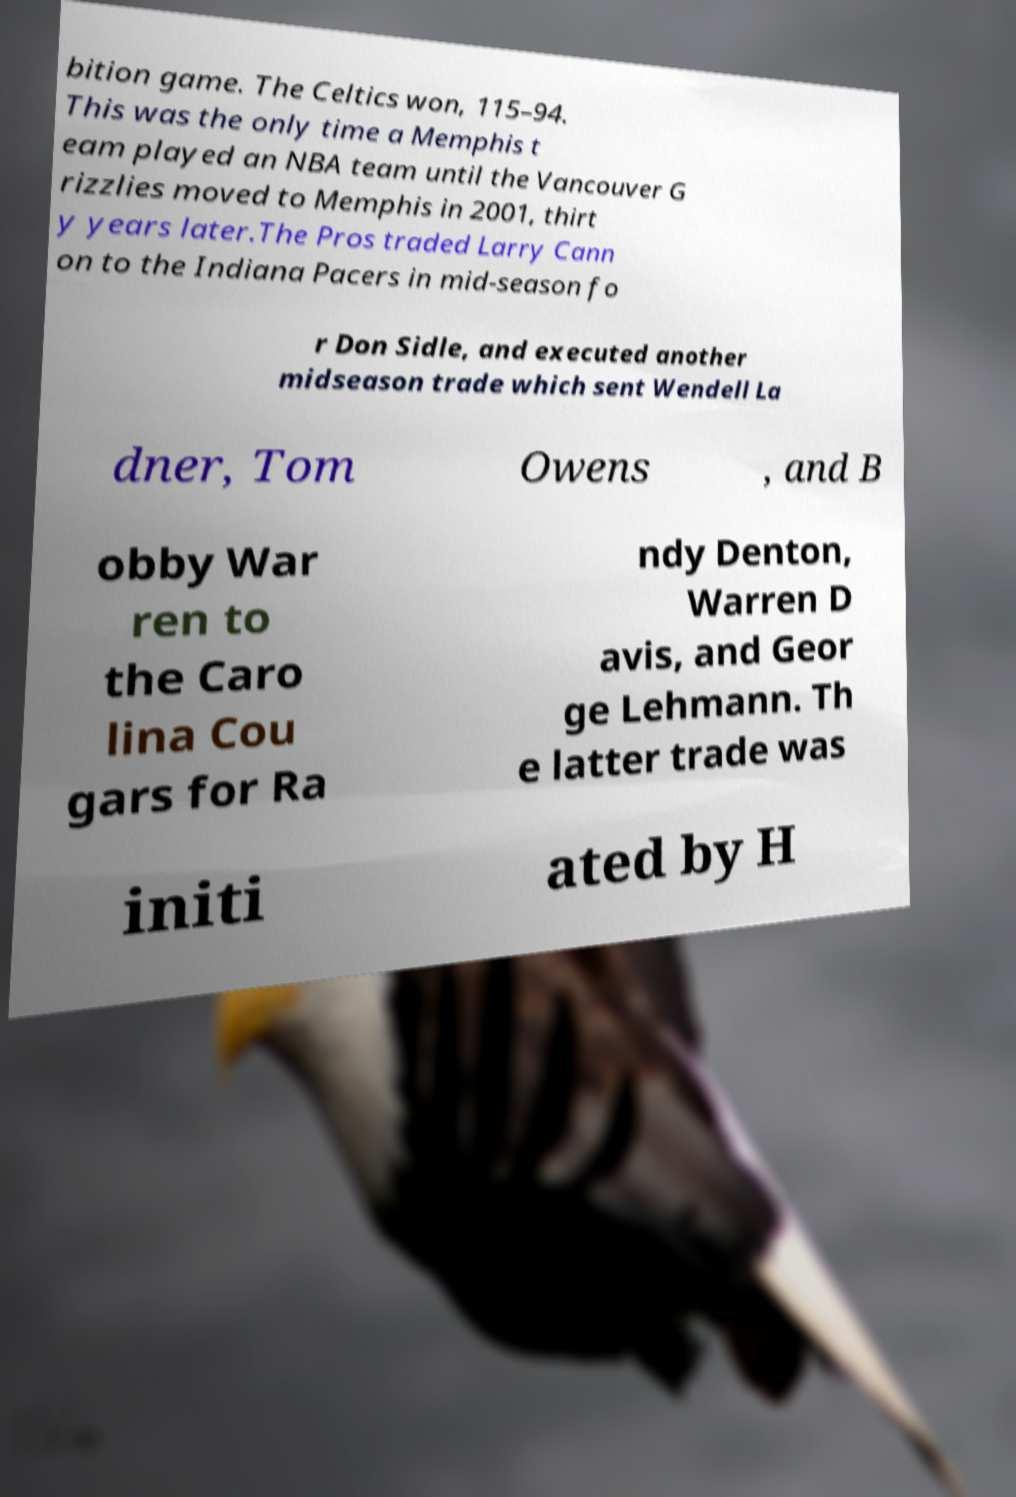There's text embedded in this image that I need extracted. Can you transcribe it verbatim? bition game. The Celtics won, 115–94. This was the only time a Memphis t eam played an NBA team until the Vancouver G rizzlies moved to Memphis in 2001, thirt y years later.The Pros traded Larry Cann on to the Indiana Pacers in mid-season fo r Don Sidle, and executed another midseason trade which sent Wendell La dner, Tom Owens , and B obby War ren to the Caro lina Cou gars for Ra ndy Denton, Warren D avis, and Geor ge Lehmann. Th e latter trade was initi ated by H 